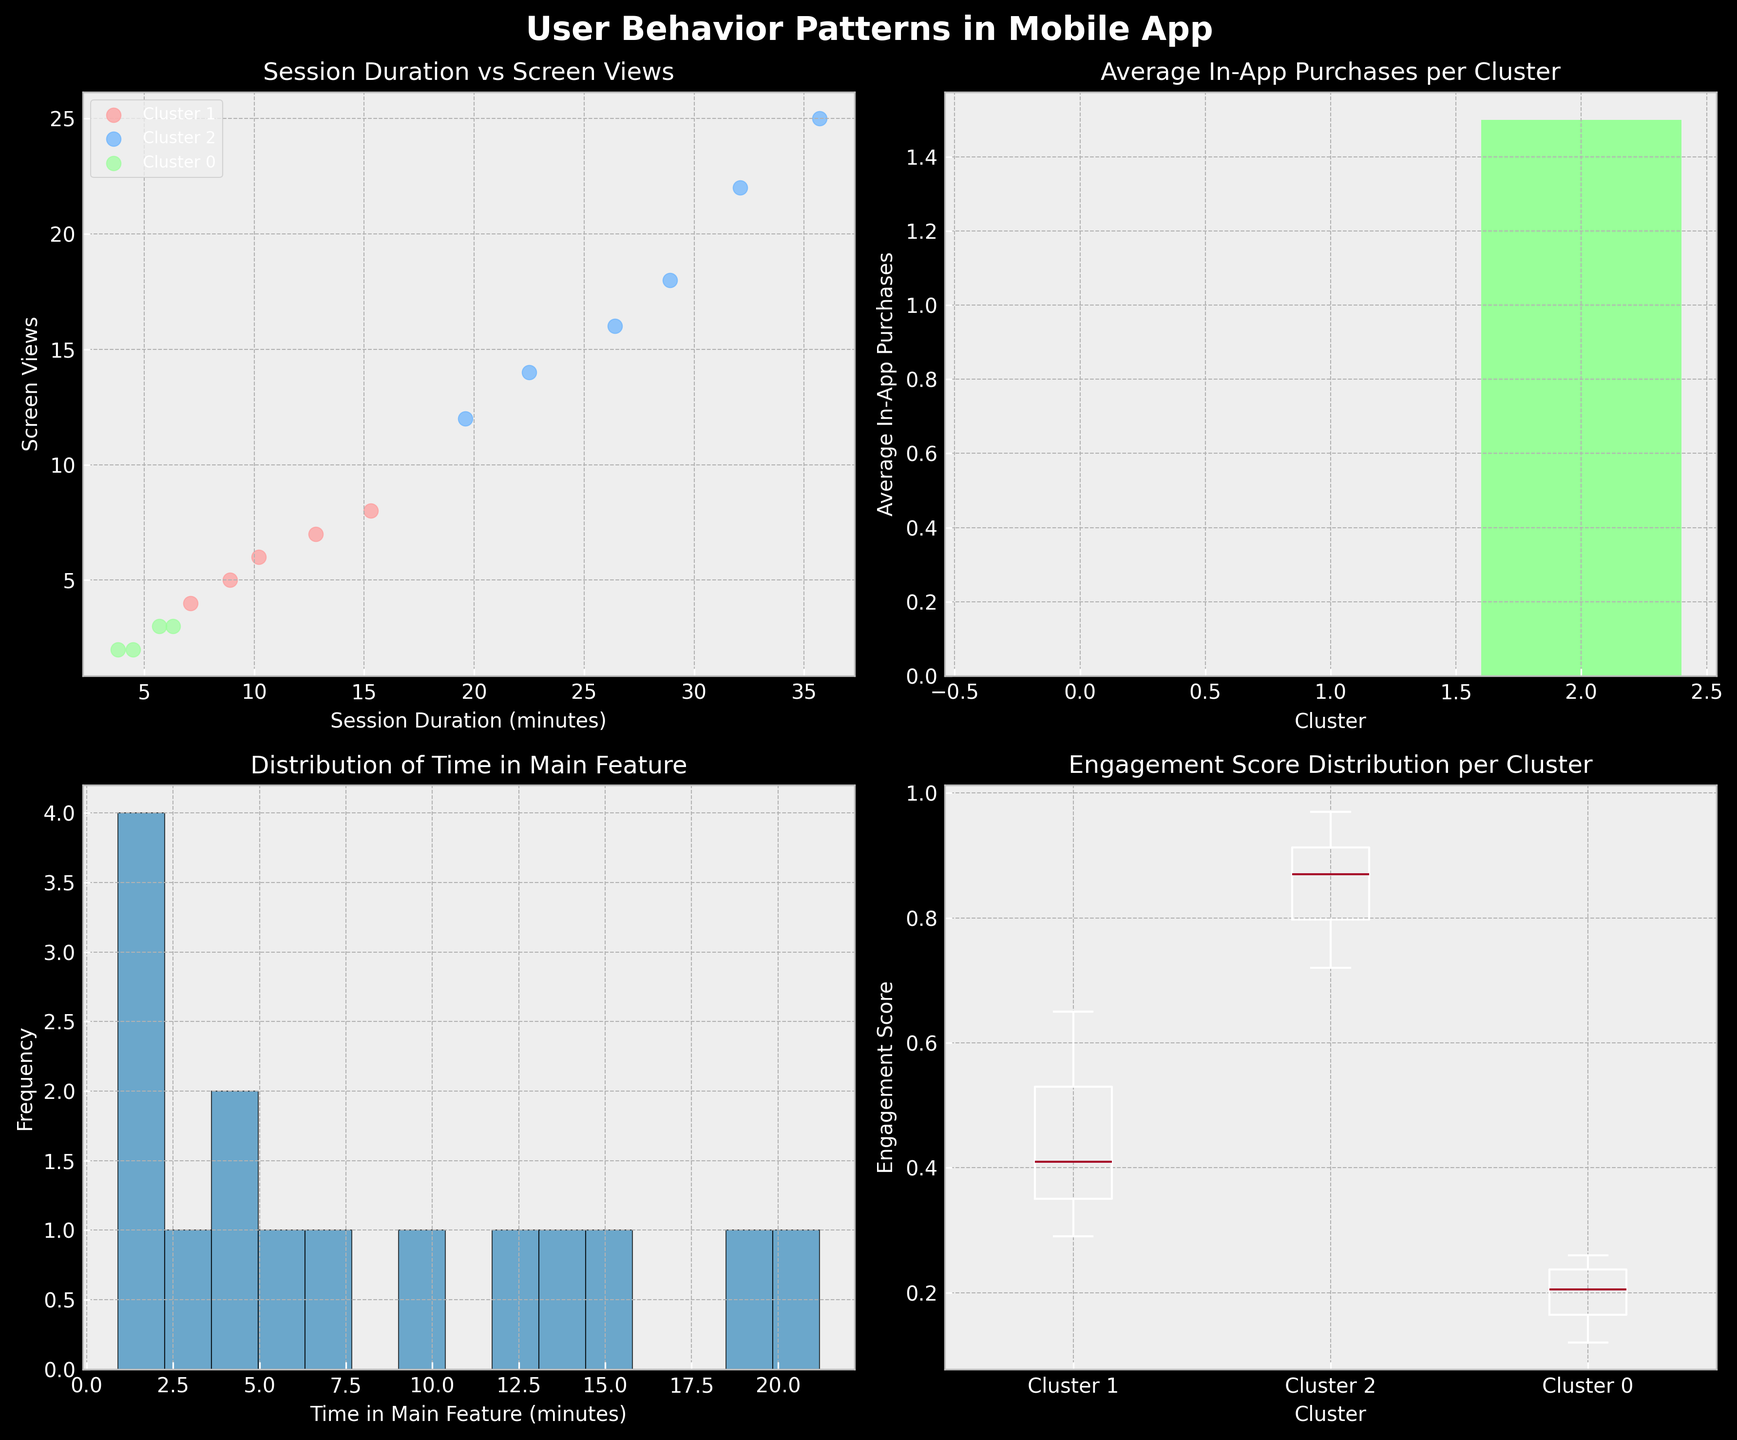What is the title of the scatter plot in the top-left subplot? The title of the scatter plot in the top-left subplot can be found directly above the plot. It reads "Session Duration vs Screen Views".
Answer: Session Duration vs Screen Views Which cluster has the highest average number of in-app purchases according to the bar plot in the top-right subplot? To determine the highest average number of in-app purchases, look at the heights of the bars in the bar plot. Cluster 2 has the highest bar, indicating it has the highest average number of in-app purchases.
Answer: Cluster 2 How many users belong to Cluster 1 based on the scatter plot? By counting the number of points (dots) in the scatter plot that are colored according to Cluster 1, we find there are 4 data points.
Answer: 4 What is the range of the engagement scores in Cluster 0 according to the box plot in the bottom-right subplot? The range of engagement scores in Cluster 0 is given by the distance between the minimum and maximum points (excluding outliers) of the first box in the box plot. The range is from approximately 0.12 to 0.26.
Answer: 0.12 to 0.26 What data does the histogram in the bottom-left subplot represent? The histogram in the bottom-left subplot represents the distribution of the variable "Time in Main Feature". This can be identified by the title and labels on the plot.
Answer: Time in Main Feature Which plot shows the distribution of a single variable without clustering information? The distribution of a single variable without differentiation by clusters is shown in a histogram, which, in this case, is the bottom-left plot titled "Distribution of Time in Main Feature".
Answer: Histogram in the bottom-left Between Clusters 1 and 2, which has a higher median engagement score? To find the higher median engagement score between Clusters 1 and 2, compare the median line inside their respective boxes in the bottom-right subplot. Cluster 2 has a higher median engagement score than Cluster 1.
Answer: Cluster 2 What is the most frequent time range users spend in the main feature according to the histogram? The most frequent time range spent in the main feature can be determined by the highest bar in the histogram in the bottom-left subplot. This highest bar is around 1-2 minutes.
Answer: 1-2 minutes 